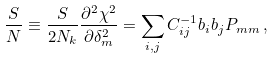<formula> <loc_0><loc_0><loc_500><loc_500>\frac { S } { N } \equiv \frac { S } { 2 N _ { k } } \frac { \partial ^ { 2 } \chi ^ { 2 } } { \partial \delta _ { m } ^ { 2 } } = \sum _ { i , j } C _ { i j } ^ { - 1 } b _ { i } b _ { j } P _ { m m } \, ,</formula> 